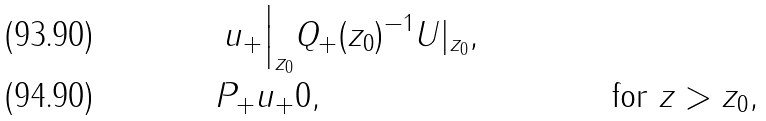<formula> <loc_0><loc_0><loc_500><loc_500>u _ { + } \Big | _ { z _ { 0 } } & Q _ { + } ( z _ { 0 } ) ^ { - 1 } U | _ { z _ { 0 } } , \\ P _ { + } u _ { + } & 0 , & & \text { for $z>z_{0}$} ,</formula> 